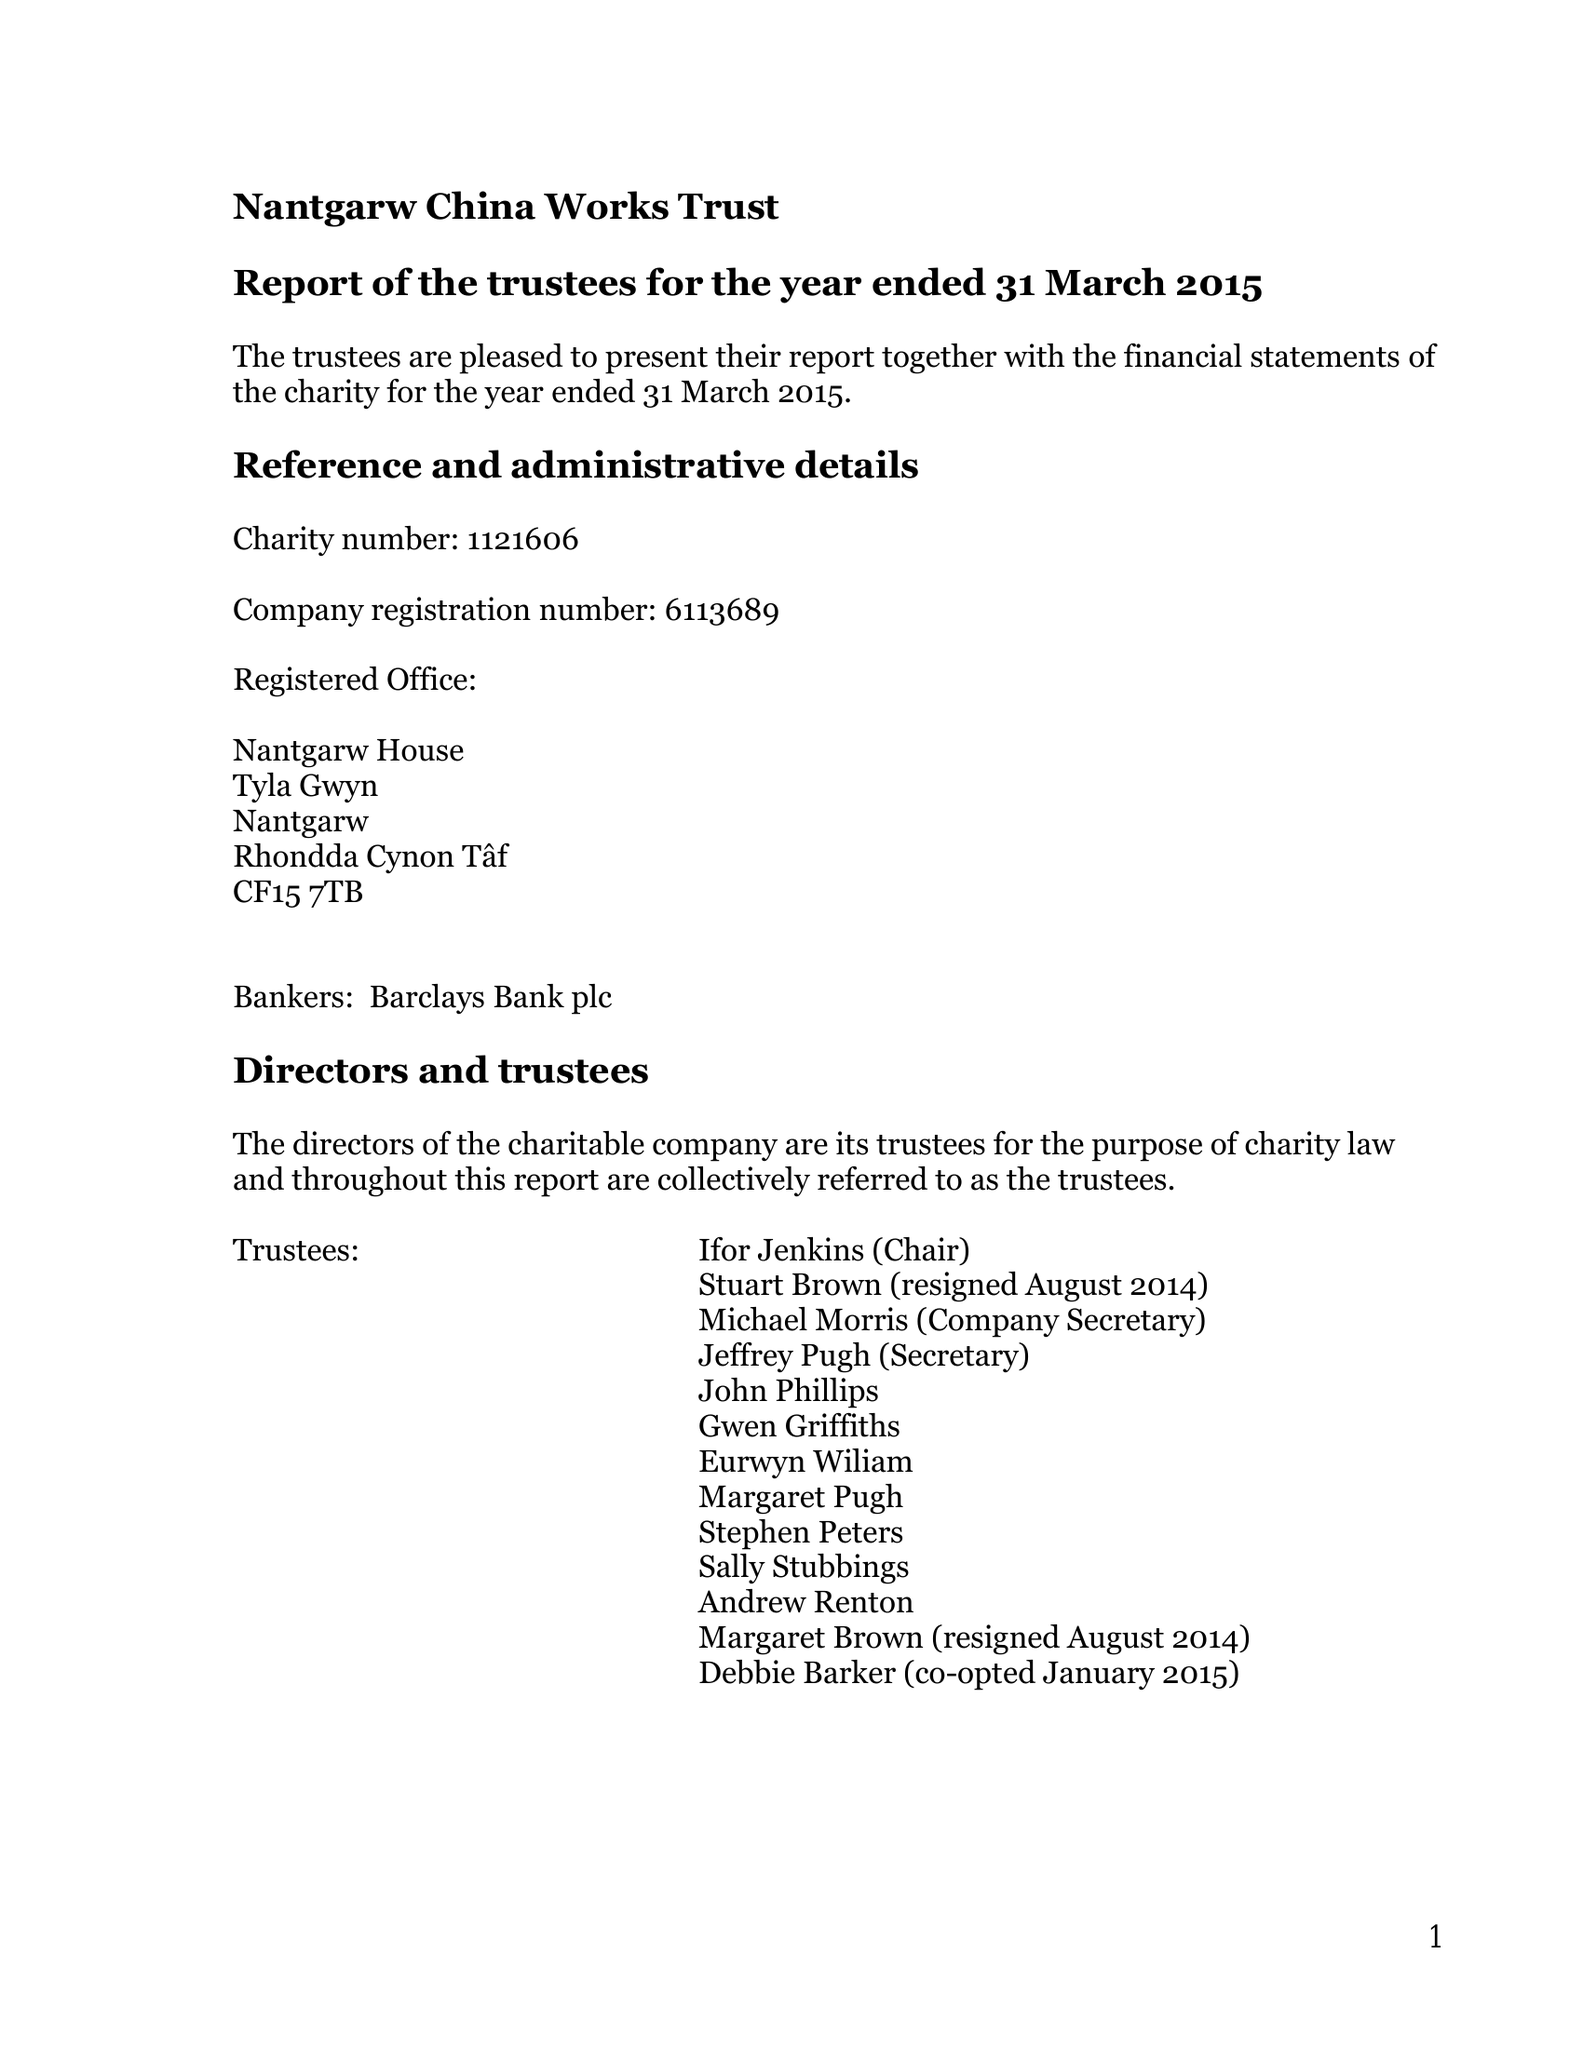What is the value for the address__street_line?
Answer the question using a single word or phrase. TYLA GWYN 